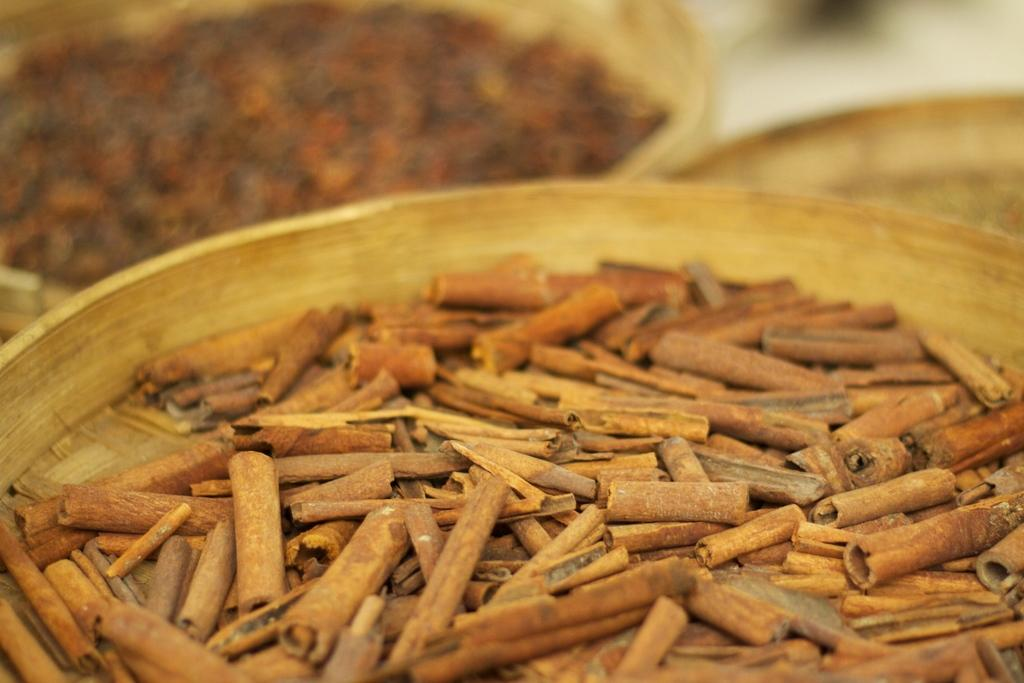What is present on the plate in the image? There are cinnamon on the plate. Can you describe the appearance of the cinnamon? The cinnamon appears to be in a powdered or ground form. Are there any bears interacting with the cinnamon on the plate in the image? No, there are no bears present in the image. What type of fruit is being cooked alongside the cinnamon in the image? There is no fruit or cooking activity depicted in the image; it only shows a plate with cinnamon. 